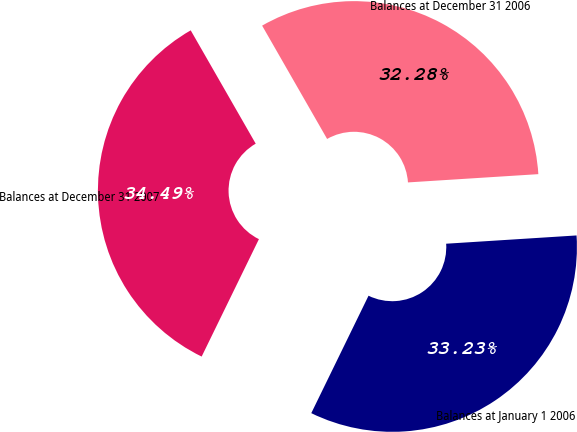Convert chart to OTSL. <chart><loc_0><loc_0><loc_500><loc_500><pie_chart><fcel>Balances at January 1 2006<fcel>Balances at December 31 2006<fcel>Balances at December 31 2007<nl><fcel>33.23%<fcel>32.28%<fcel>34.49%<nl></chart> 